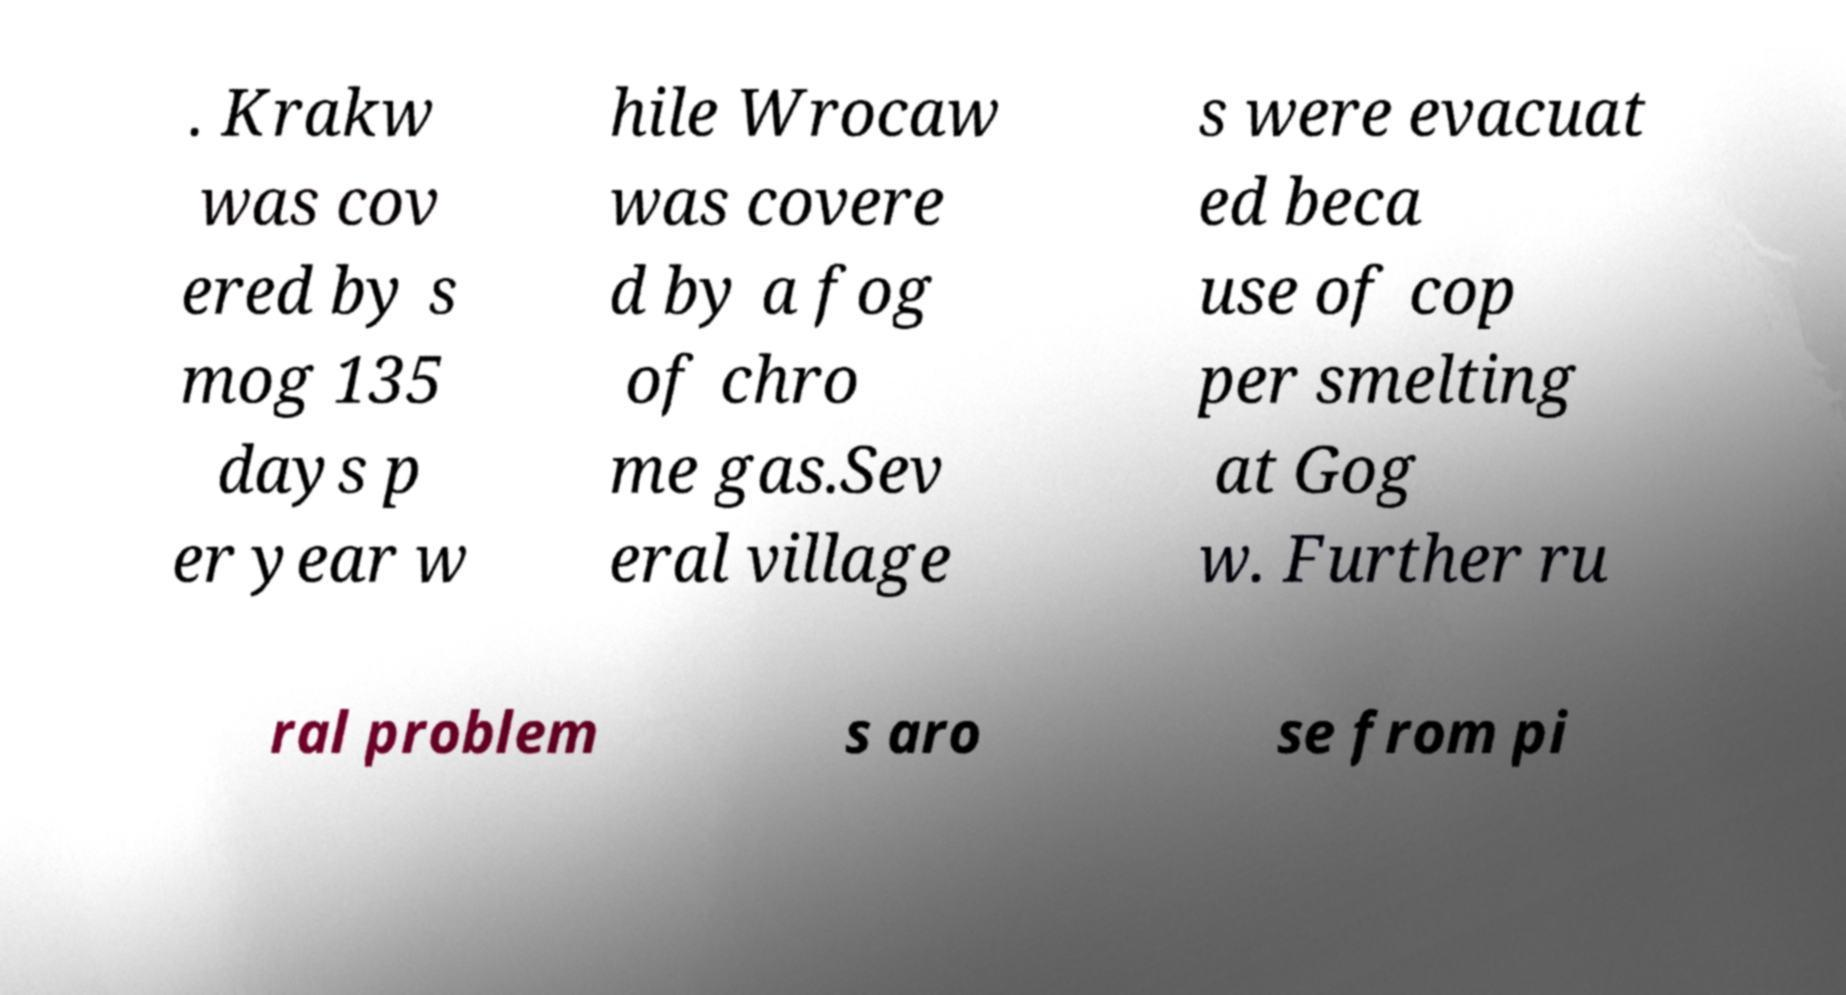Can you read and provide the text displayed in the image?This photo seems to have some interesting text. Can you extract and type it out for me? . Krakw was cov ered by s mog 135 days p er year w hile Wrocaw was covere d by a fog of chro me gas.Sev eral village s were evacuat ed beca use of cop per smelting at Gog w. Further ru ral problem s aro se from pi 